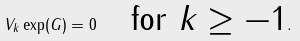<formula> <loc_0><loc_0><loc_500><loc_500>V _ { k } \exp ( G ) = 0 \quad \text {for $k\geq -1$} .</formula> 